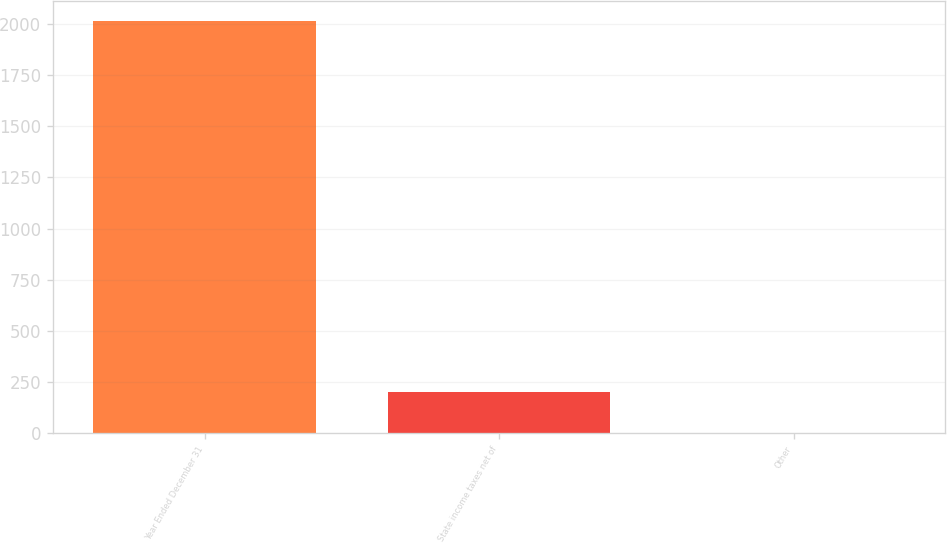Convert chart to OTSL. <chart><loc_0><loc_0><loc_500><loc_500><bar_chart><fcel>Year Ended December 31<fcel>State income taxes net of<fcel>Other<nl><fcel>2012<fcel>201.38<fcel>0.2<nl></chart> 